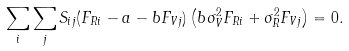<formula> <loc_0><loc_0><loc_500><loc_500>\sum _ { i } \sum _ { j } S _ { i j } ( F _ { R i } - a - b F _ { V j } ) \left ( b \sigma _ { V } ^ { 2 } F _ { R i } + \sigma _ { R } ^ { 2 } F _ { V j } \right ) = 0 .</formula> 